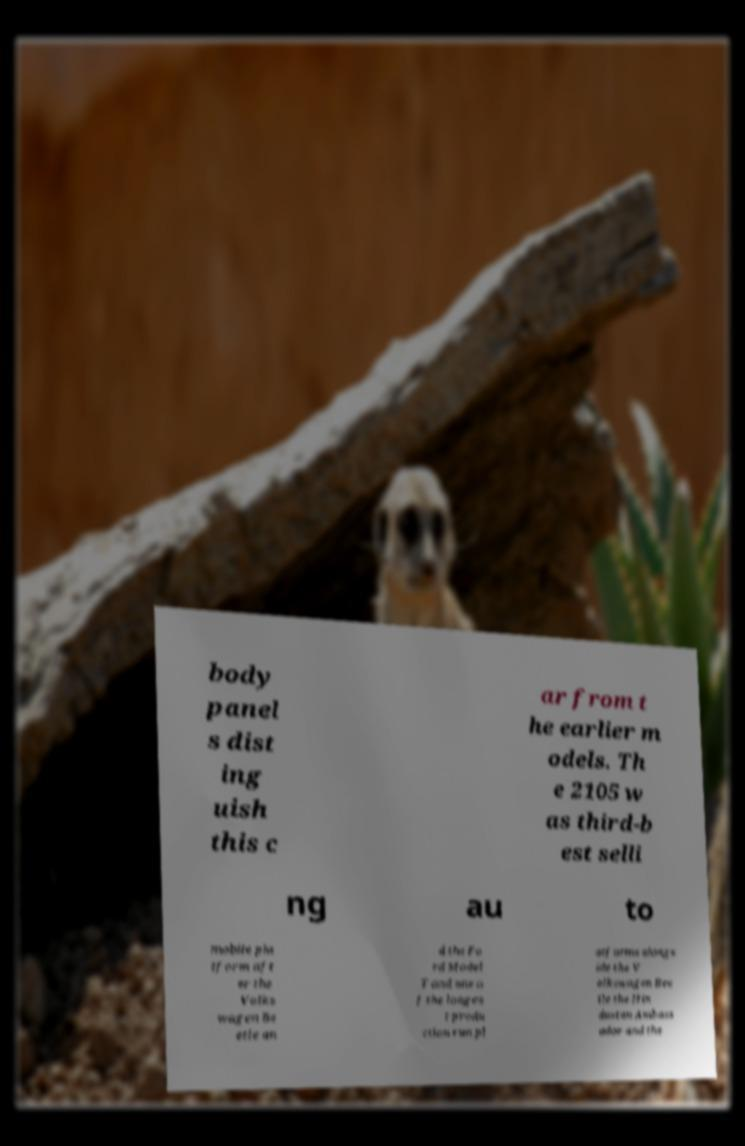Can you read and provide the text displayed in the image?This photo seems to have some interesting text. Can you extract and type it out for me? body panel s dist ing uish this c ar from t he earlier m odels. Th e 2105 w as third-b est selli ng au to mobile pla tform aft er the Volks wagen Be etle an d the Fo rd Model T and one o f the longes t produ ction run pl atforms alongs ide the V olkswagen Bee tle the Hin dustan Ambass ador and the 